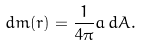Convert formula to latex. <formula><loc_0><loc_0><loc_500><loc_500>d m ( r ) = \frac { 1 } { 4 \pi } a \, d A .</formula> 